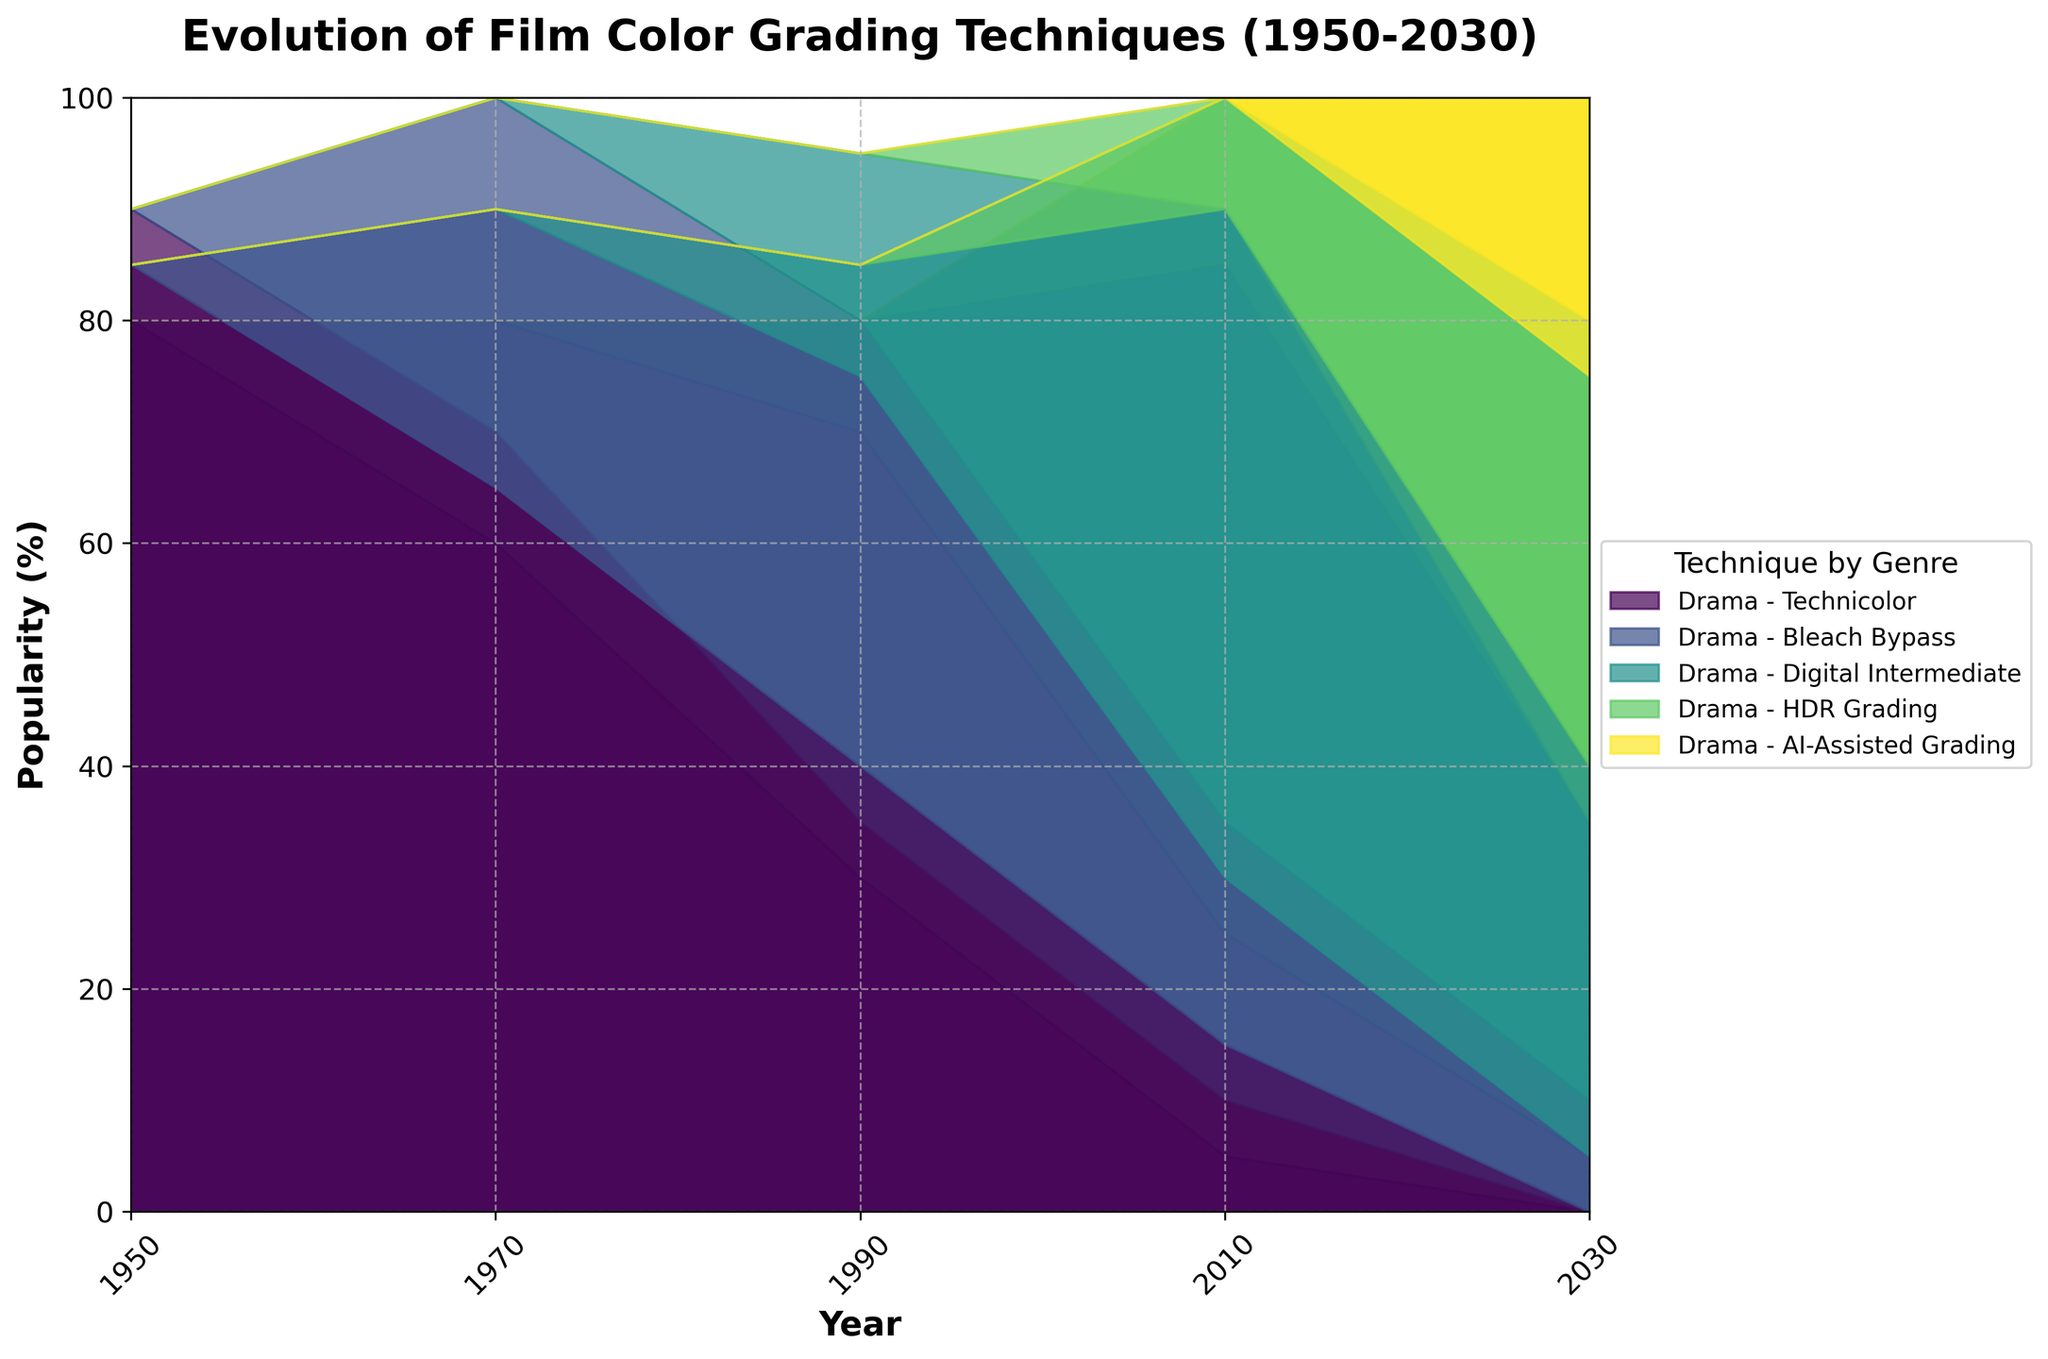what is the title of the figure? The title of the figure is located at the top and is formatted in bold. It reads "Evolution of Film Color Grading Techniques (1950-2030)."
Answer: Evolution of Film Color Grading Techniques (1950-2030) which genre had the highest use of Technicolor in 1950? To determine this, look at the percentage values for Technicolor in 1950 for each genre. The Action genre has the highest value at 90%.
Answer: Action how did the usage of Bleach Bypass change for the Drama genre from 1970 to 2030? In 1970, Bleach Bypass usage in Drama was 20%. By 2030, it decreased to 5%.
Answer: Decreased which grading technique became most popular from 2010 to 2030 for the Comedy genre? Check the percentages for each technique in the Comedy genre for the years 2010 and 2030. Digital Intermediate had the highest usage in 2010 at 60%, but HDR Grading was 35% and AI-Assisted Grading was 25% in 2030. Hence, HDR Grading and AI-Assisted Grading grew significantly.
Answer: HDR Grading and AI-Assisted Grading which genre had shown the greatest diversification of color grading techniques in 2030? Diversification can be measured by looking at the spread among techniques in 2030. The Action genre distributes its usage among Bleach Bypass, Digital Intermediate, HDR Grading, and AI-Assisted Grading, suggesting a lower reliance on any single technique.
Answer: Action in which year did the Digital Intermediate technique first appear and in which genre? Observing the percentages of Digital Intermediate across the years, it first appears in 1990 in the genres of Drama, Action, and Comedy, with minor percentages.
Answer: 1990, Drama, Action, Comedy what is the trend for AI-Assisted Grading from 1950 to 2030 for the Drama genre? Starting with 0% in 1950, AI-Assisted Grading appears only in 2030 with a percentage of 25%.
Answer: Increasing compare the popularity of HDR Grading between the Action and Comedy genres in 2030. For 2030, looking at HDR Grading, Action has 45% whereas Comedy has 35%.
Answer: Action for which year and grading technique is the total percentage distributed among all genres balanced? Analyzing the distribution across techniques and years, in 2010 most techniques show a fair spread unlike later years where specific genres dominate specific techniques.
Answer: 2010 